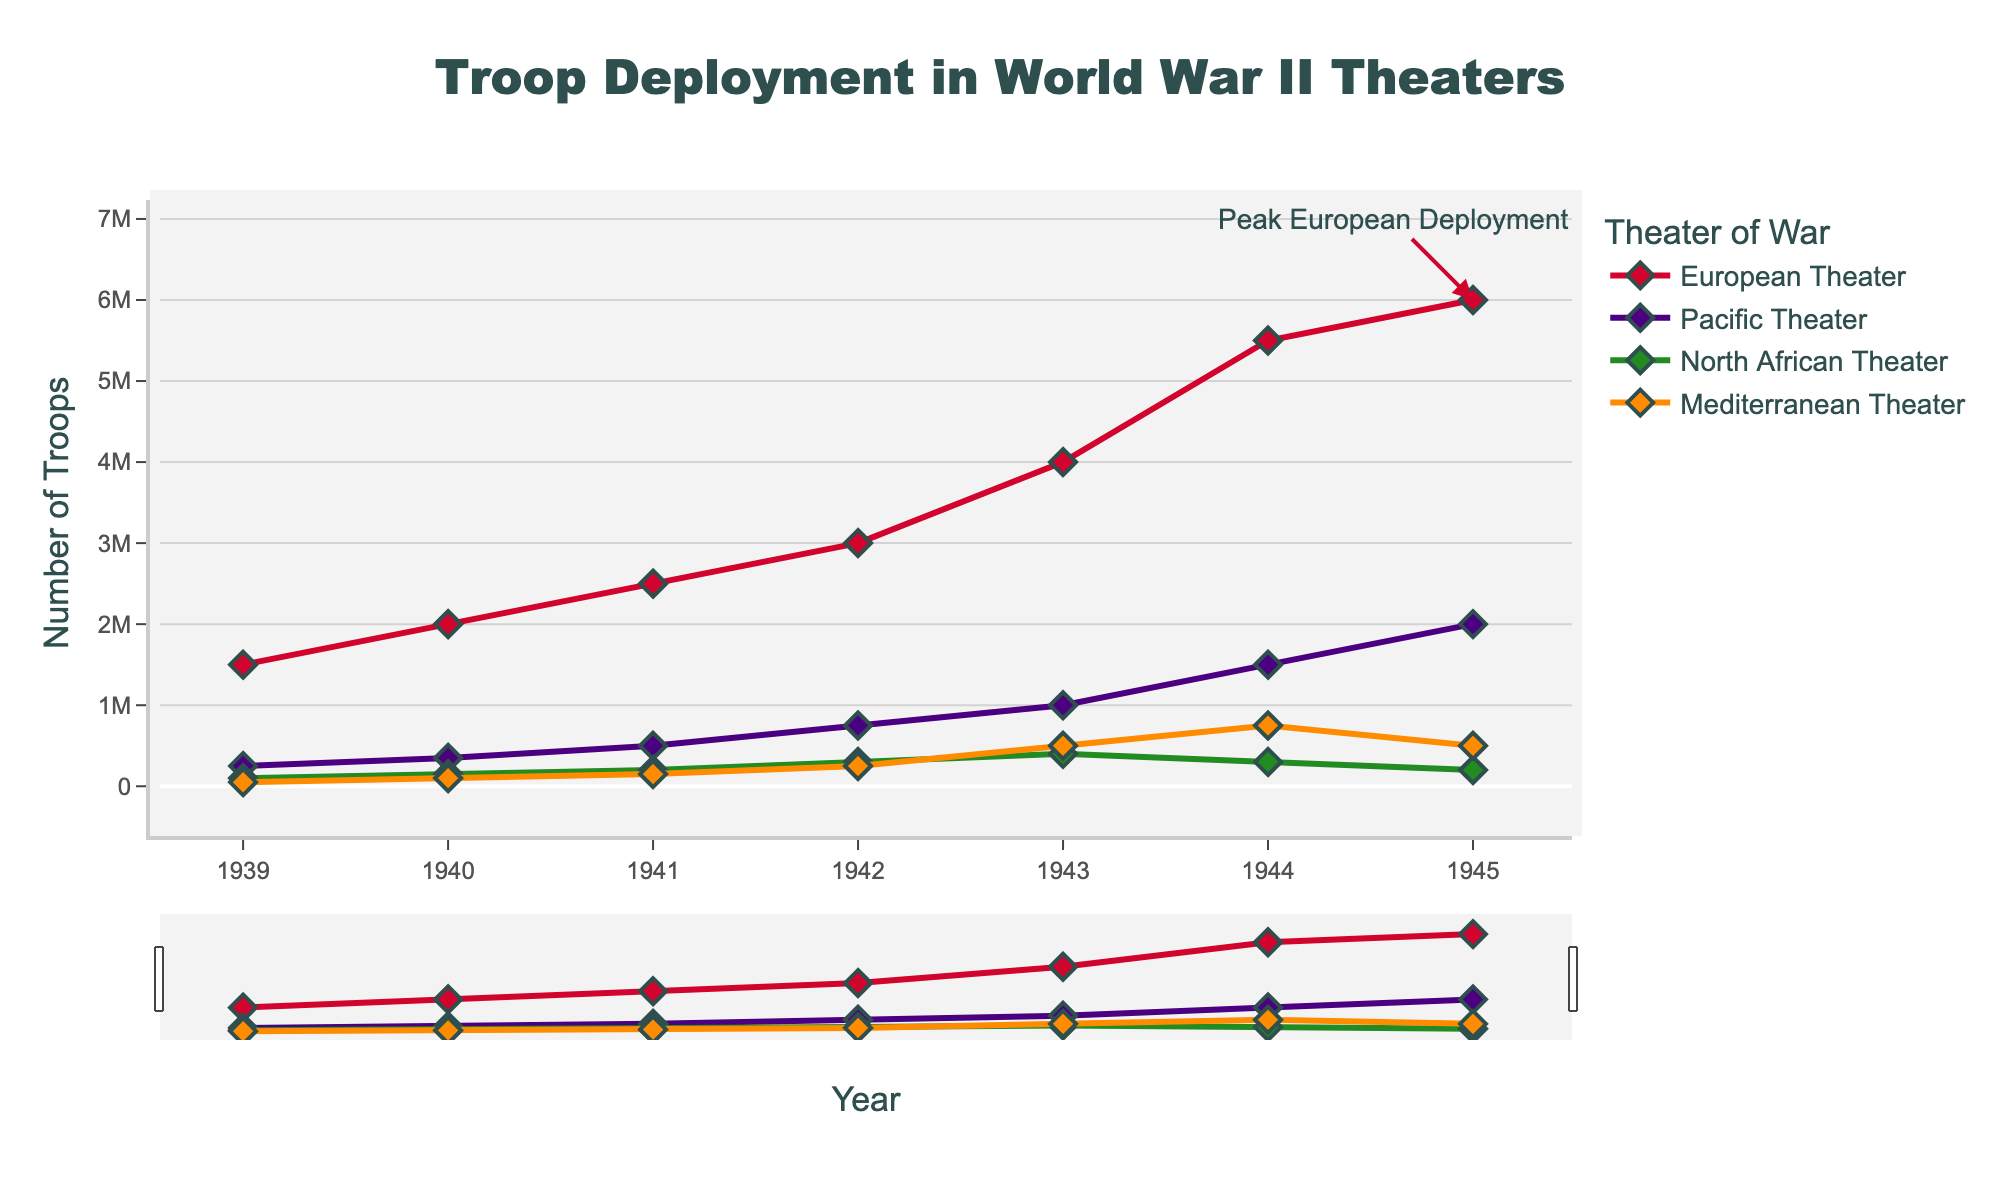What year had the highest troop deployment in the European Theater? By looking at the plotted line for the European Theater, we can identify the peak point. The annotation also marks "Peak European Deployment" in 1945.
Answer: 1945 Which theater showed the largest increase in troop deployment between 1939 and 1945? Calculate the difference in troop deployment for each theater between 1939 and 1945: European Theater (6000000 - 1500000 = 4500000), Pacific Theater (2000000 - 250000 = 1750000), North African Theater (200000 - 100000 = 100000), Mediterranean Theater (500000 - 50000 = 450000). The European Theater has the largest increase.
Answer: European Theater What color represents the troop deployment in the Mediterranean Theater? Refer to the plot legend; the Mediterranean Theater is represented by an orange line and markers.
Answer: Orange Compared to the European Theater, did the North African Theater have a higher or lower troop deployment in 1944? In 1944, the European Theater had 5500000 troops, and the North African Theater had 300000 troops. The North African Theater had significantly lower troop deployment.
Answer: Lower What is the total number of troops deployed in the Pacific Theater from 1939 to 1945? Add the troop numbers for the Pacific Theater from 1939 to 1945: 250000 + 350000 + 500000 + 750000 + 1000000 + 1500000 + 2000000 = 6350000.
Answer: 6350000 In which year did the North African Theater experience the highest troop deployment? By checking the plotted line for the North African Theater and its highest point, we can see that the maximum occurred in 1943 with 400000 troops.
Answer: 1943 How does the increase in troop deployment from 1940 to 1942 in the Mediterranean Theater compare to that in the Pacific Theater? Compute the change for each: Mediterranean Theater (250000 - 100000 = 150000), Pacific Theater (750000 - 350000 = 400000). The increase is larger in the Pacific Theater.
Answer: Pacific Theater What is the average number of troops deployed in the Mediterranean Theater from 1939 to 1945? Sum the troop numbers for the Mediterranean Theater from 1939 to 1945: 50000 + 100000 + 150000 + 250000 + 500000 + 750000 + 500000 = 2300000. There are 7 years, so the average is 2300000 / 7 ≈ 328571 (rounded to the nearest whole number).
Answer: 328571 